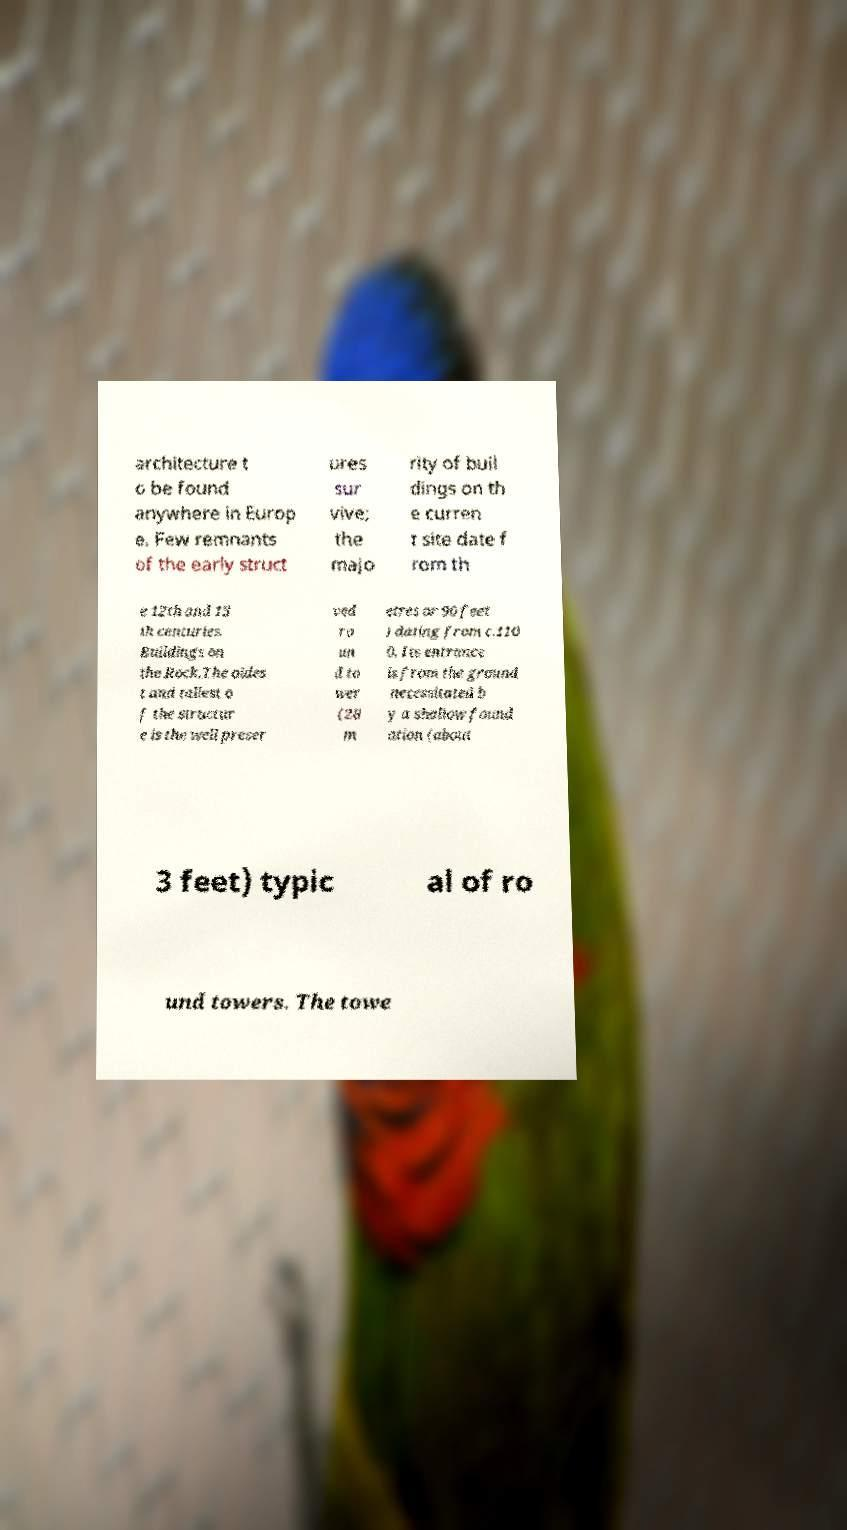Could you extract and type out the text from this image? architecture t o be found anywhere in Europ e. Few remnants of the early struct ures sur vive; the majo rity of buil dings on th e curren t site date f rom th e 12th and 13 th centuries. Buildings on the Rock.The oldes t and tallest o f the structur e is the well preser ved ro un d to wer (28 m etres or 90 feet ) dating from c.110 0. Its entrance is from the ground necessitated b y a shallow found ation (about 3 feet) typic al of ro und towers. The towe 